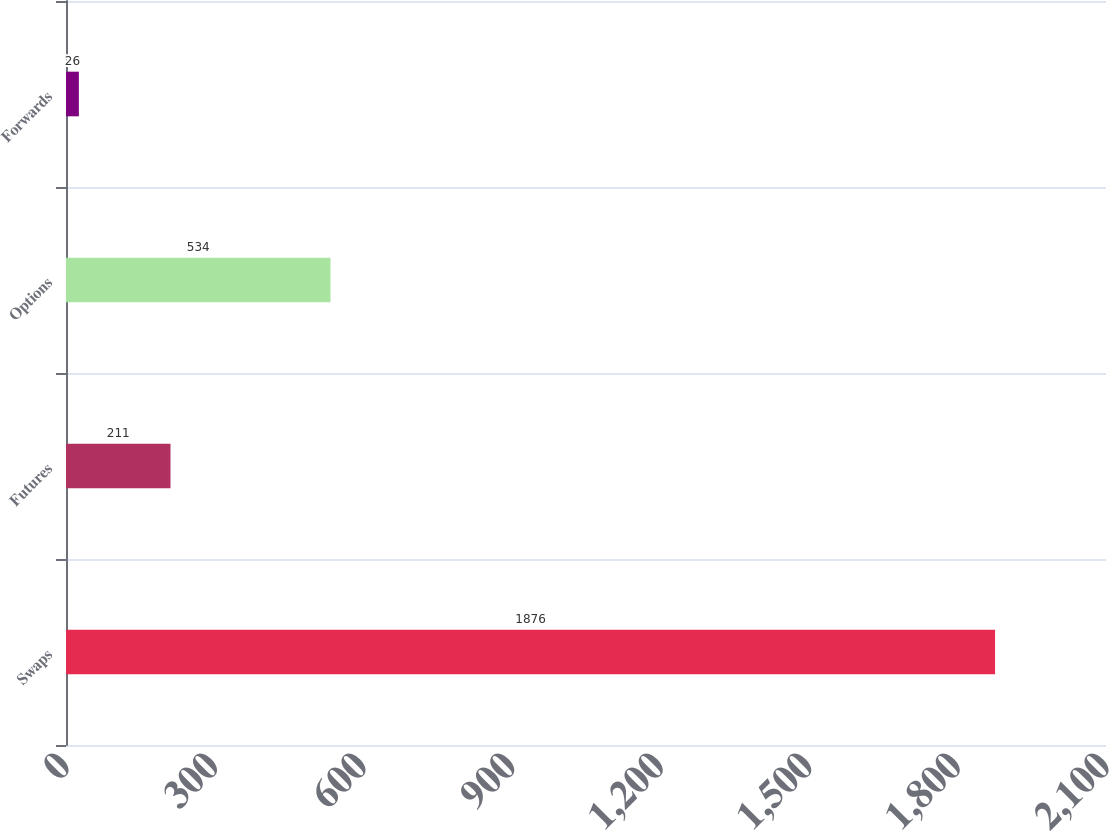Convert chart. <chart><loc_0><loc_0><loc_500><loc_500><bar_chart><fcel>Swaps<fcel>Futures<fcel>Options<fcel>Forwards<nl><fcel>1876<fcel>211<fcel>534<fcel>26<nl></chart> 